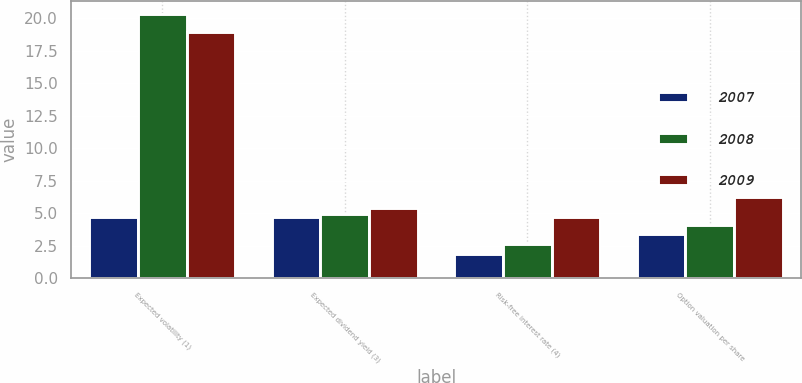<chart> <loc_0><loc_0><loc_500><loc_500><stacked_bar_chart><ecel><fcel>Expected volatility (1)<fcel>Expected dividend yield (3)<fcel>Risk-free interest rate (4)<fcel>Option valuation per share<nl><fcel>2007<fcel>4.74<fcel>4.68<fcel>1.89<fcel>3.38<nl><fcel>2008<fcel>20.3<fcel>4.95<fcel>2.67<fcel>4.08<nl><fcel>2009<fcel>18.9<fcel>5.41<fcel>4.74<fcel>6.26<nl></chart> 